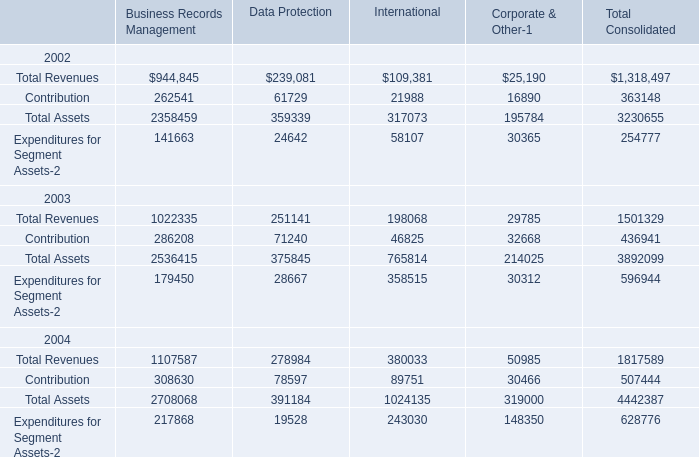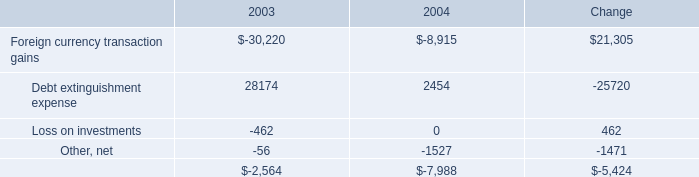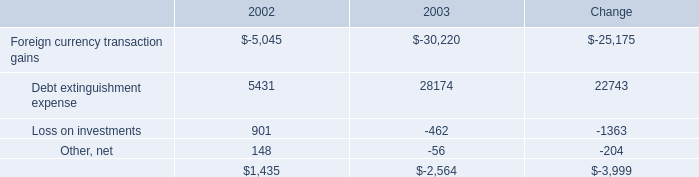What's the growth rate of Contribution for Data Protection in 2003? 
Computations: ((71240 - 61729) / 61729)
Answer: 0.15408. 